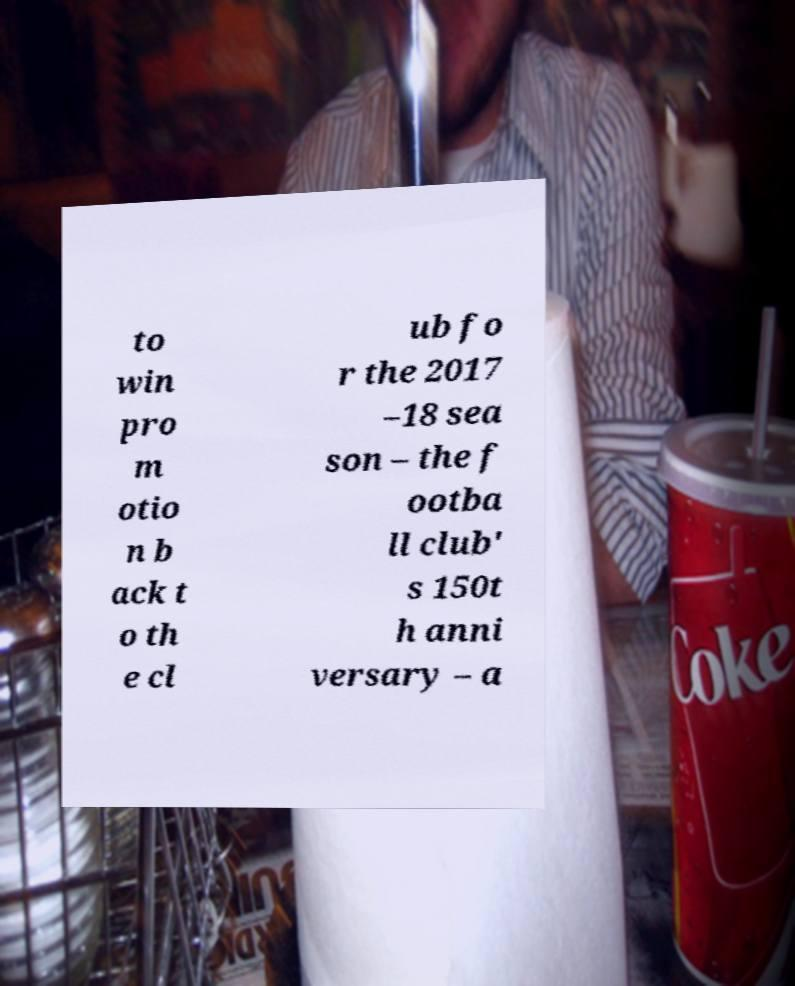Please identify and transcribe the text found in this image. to win pro m otio n b ack t o th e cl ub fo r the 2017 –18 sea son – the f ootba ll club' s 150t h anni versary – a 